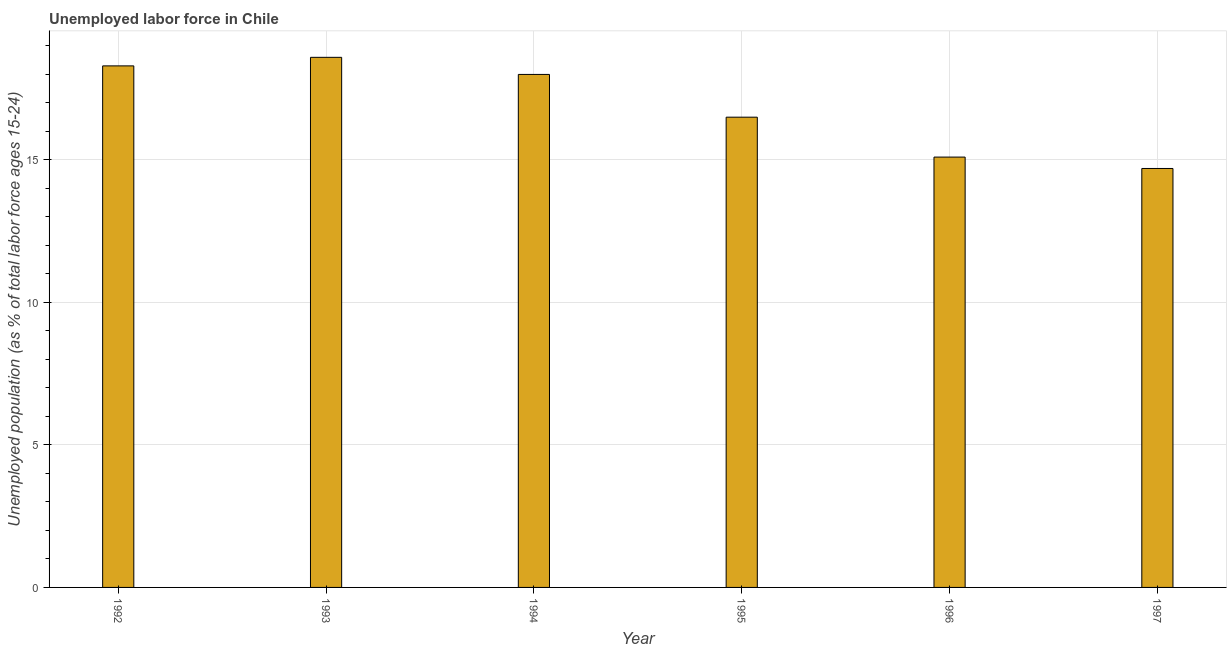What is the title of the graph?
Your answer should be very brief. Unemployed labor force in Chile. What is the label or title of the X-axis?
Ensure brevity in your answer.  Year. What is the label or title of the Y-axis?
Your answer should be compact. Unemployed population (as % of total labor force ages 15-24). What is the total unemployed youth population in 1997?
Offer a terse response. 14.7. Across all years, what is the maximum total unemployed youth population?
Your answer should be compact. 18.6. Across all years, what is the minimum total unemployed youth population?
Make the answer very short. 14.7. In which year was the total unemployed youth population maximum?
Ensure brevity in your answer.  1993. What is the sum of the total unemployed youth population?
Provide a short and direct response. 101.2. What is the average total unemployed youth population per year?
Offer a very short reply. 16.87. What is the median total unemployed youth population?
Offer a very short reply. 17.25. Is the total unemployed youth population in 1993 less than that in 1994?
Offer a very short reply. No. Is the sum of the total unemployed youth population in 1994 and 1996 greater than the maximum total unemployed youth population across all years?
Your response must be concise. Yes. How many bars are there?
Your answer should be very brief. 6. What is the Unemployed population (as % of total labor force ages 15-24) of 1992?
Your response must be concise. 18.3. What is the Unemployed population (as % of total labor force ages 15-24) in 1993?
Ensure brevity in your answer.  18.6. What is the Unemployed population (as % of total labor force ages 15-24) in 1996?
Make the answer very short. 15.1. What is the Unemployed population (as % of total labor force ages 15-24) of 1997?
Your response must be concise. 14.7. What is the difference between the Unemployed population (as % of total labor force ages 15-24) in 1992 and 1993?
Your response must be concise. -0.3. What is the difference between the Unemployed population (as % of total labor force ages 15-24) in 1993 and 1995?
Provide a succinct answer. 2.1. What is the difference between the Unemployed population (as % of total labor force ages 15-24) in 1994 and 1995?
Give a very brief answer. 1.5. What is the difference between the Unemployed population (as % of total labor force ages 15-24) in 1995 and 1996?
Keep it short and to the point. 1.4. What is the ratio of the Unemployed population (as % of total labor force ages 15-24) in 1992 to that in 1993?
Offer a very short reply. 0.98. What is the ratio of the Unemployed population (as % of total labor force ages 15-24) in 1992 to that in 1995?
Your answer should be compact. 1.11. What is the ratio of the Unemployed population (as % of total labor force ages 15-24) in 1992 to that in 1996?
Your answer should be very brief. 1.21. What is the ratio of the Unemployed population (as % of total labor force ages 15-24) in 1992 to that in 1997?
Make the answer very short. 1.25. What is the ratio of the Unemployed population (as % of total labor force ages 15-24) in 1993 to that in 1994?
Offer a terse response. 1.03. What is the ratio of the Unemployed population (as % of total labor force ages 15-24) in 1993 to that in 1995?
Your answer should be compact. 1.13. What is the ratio of the Unemployed population (as % of total labor force ages 15-24) in 1993 to that in 1996?
Keep it short and to the point. 1.23. What is the ratio of the Unemployed population (as % of total labor force ages 15-24) in 1993 to that in 1997?
Ensure brevity in your answer.  1.26. What is the ratio of the Unemployed population (as % of total labor force ages 15-24) in 1994 to that in 1995?
Make the answer very short. 1.09. What is the ratio of the Unemployed population (as % of total labor force ages 15-24) in 1994 to that in 1996?
Provide a succinct answer. 1.19. What is the ratio of the Unemployed population (as % of total labor force ages 15-24) in 1994 to that in 1997?
Your response must be concise. 1.22. What is the ratio of the Unemployed population (as % of total labor force ages 15-24) in 1995 to that in 1996?
Your answer should be compact. 1.09. What is the ratio of the Unemployed population (as % of total labor force ages 15-24) in 1995 to that in 1997?
Provide a succinct answer. 1.12. 